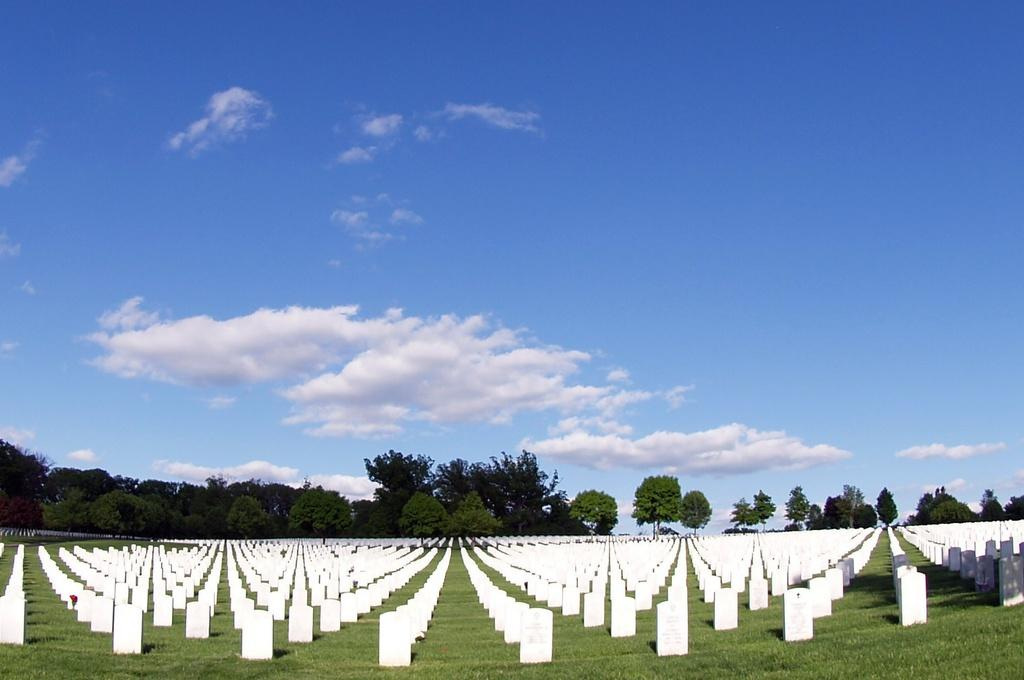What is the main subject of the image? There is a graveyard in the image. What can be seen in the background of the image? There are trees and the sky visible in the background of the image. What is the condition of the sky in the image? Clouds are present in the sky. What type of juice is being served at the graveyard in the image? There is no juice or any indication of a gathering in the image; it is a graveyard with trees and a cloudy sky in the background. 